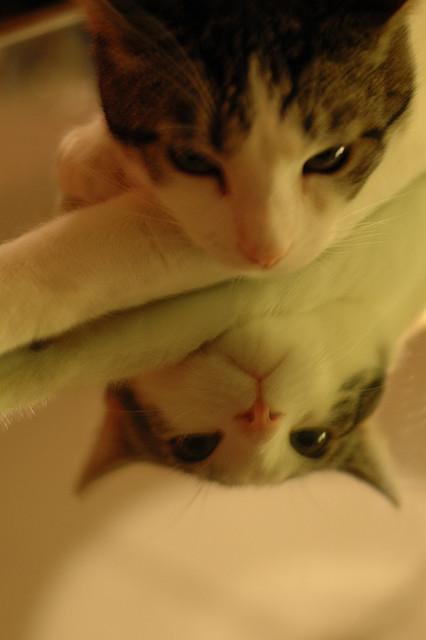How many cats are there?
Give a very brief answer. 2. How many giraffes are here?
Give a very brief answer. 0. 